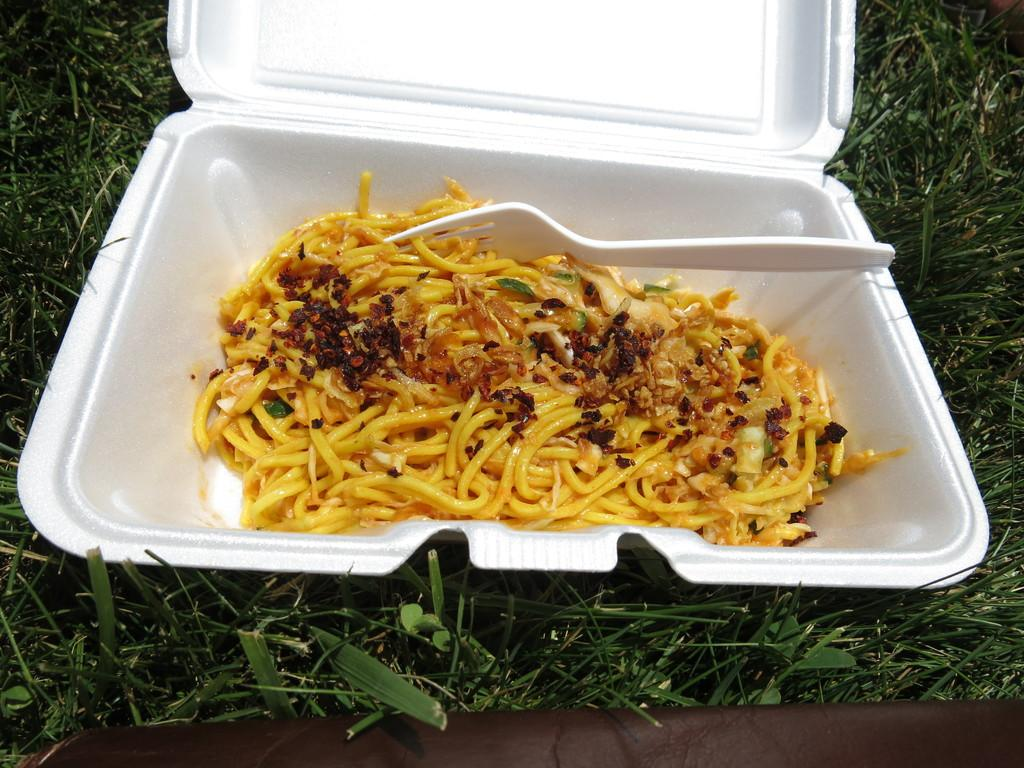What object is present in the image that contains something? There is a box in the image that contains noodles. What is used for eating the contents of the box? There is a fork in the box that can be used for eating the noodles. Where are the box and fork located? The box and fork are on grassland. How many books can be seen on the grassland in the image? There are no books visible in the image; it only shows a box containing noodles and a fork on grassland. 